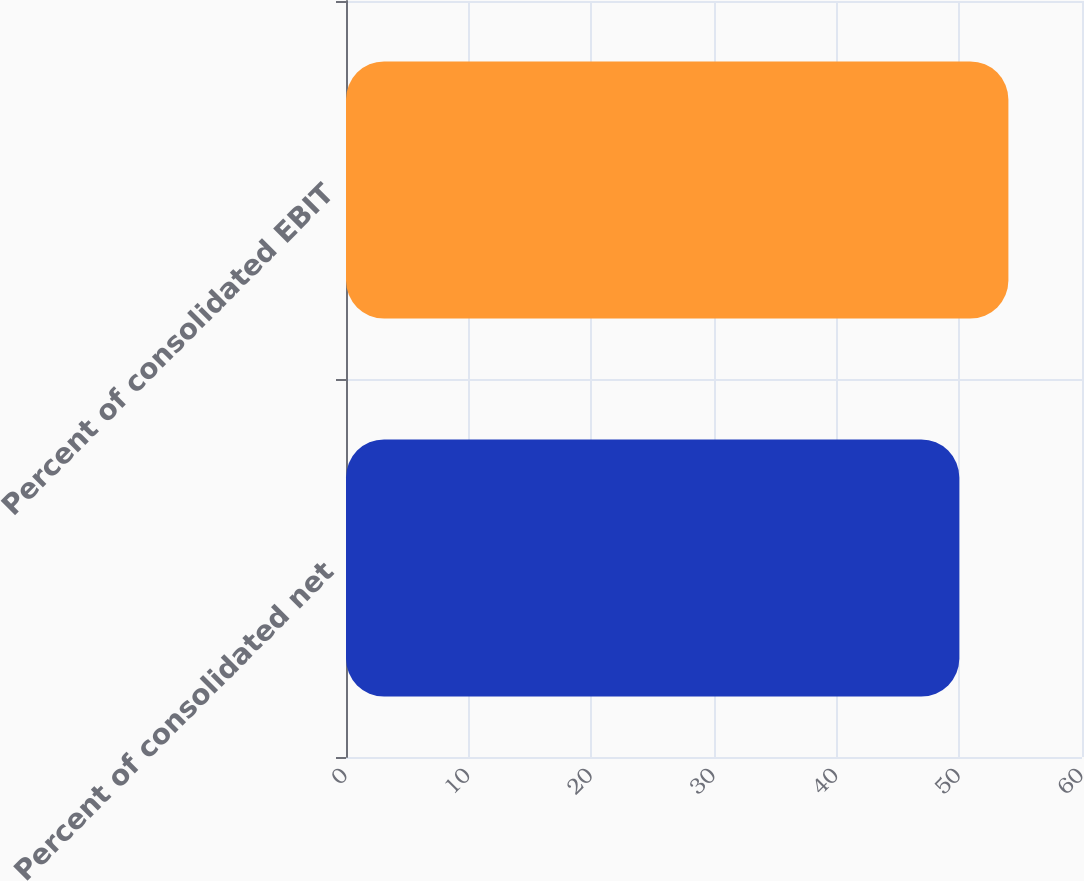Convert chart to OTSL. <chart><loc_0><loc_0><loc_500><loc_500><bar_chart><fcel>Percent of consolidated net<fcel>Percent of consolidated EBIT<nl><fcel>50<fcel>54<nl></chart> 